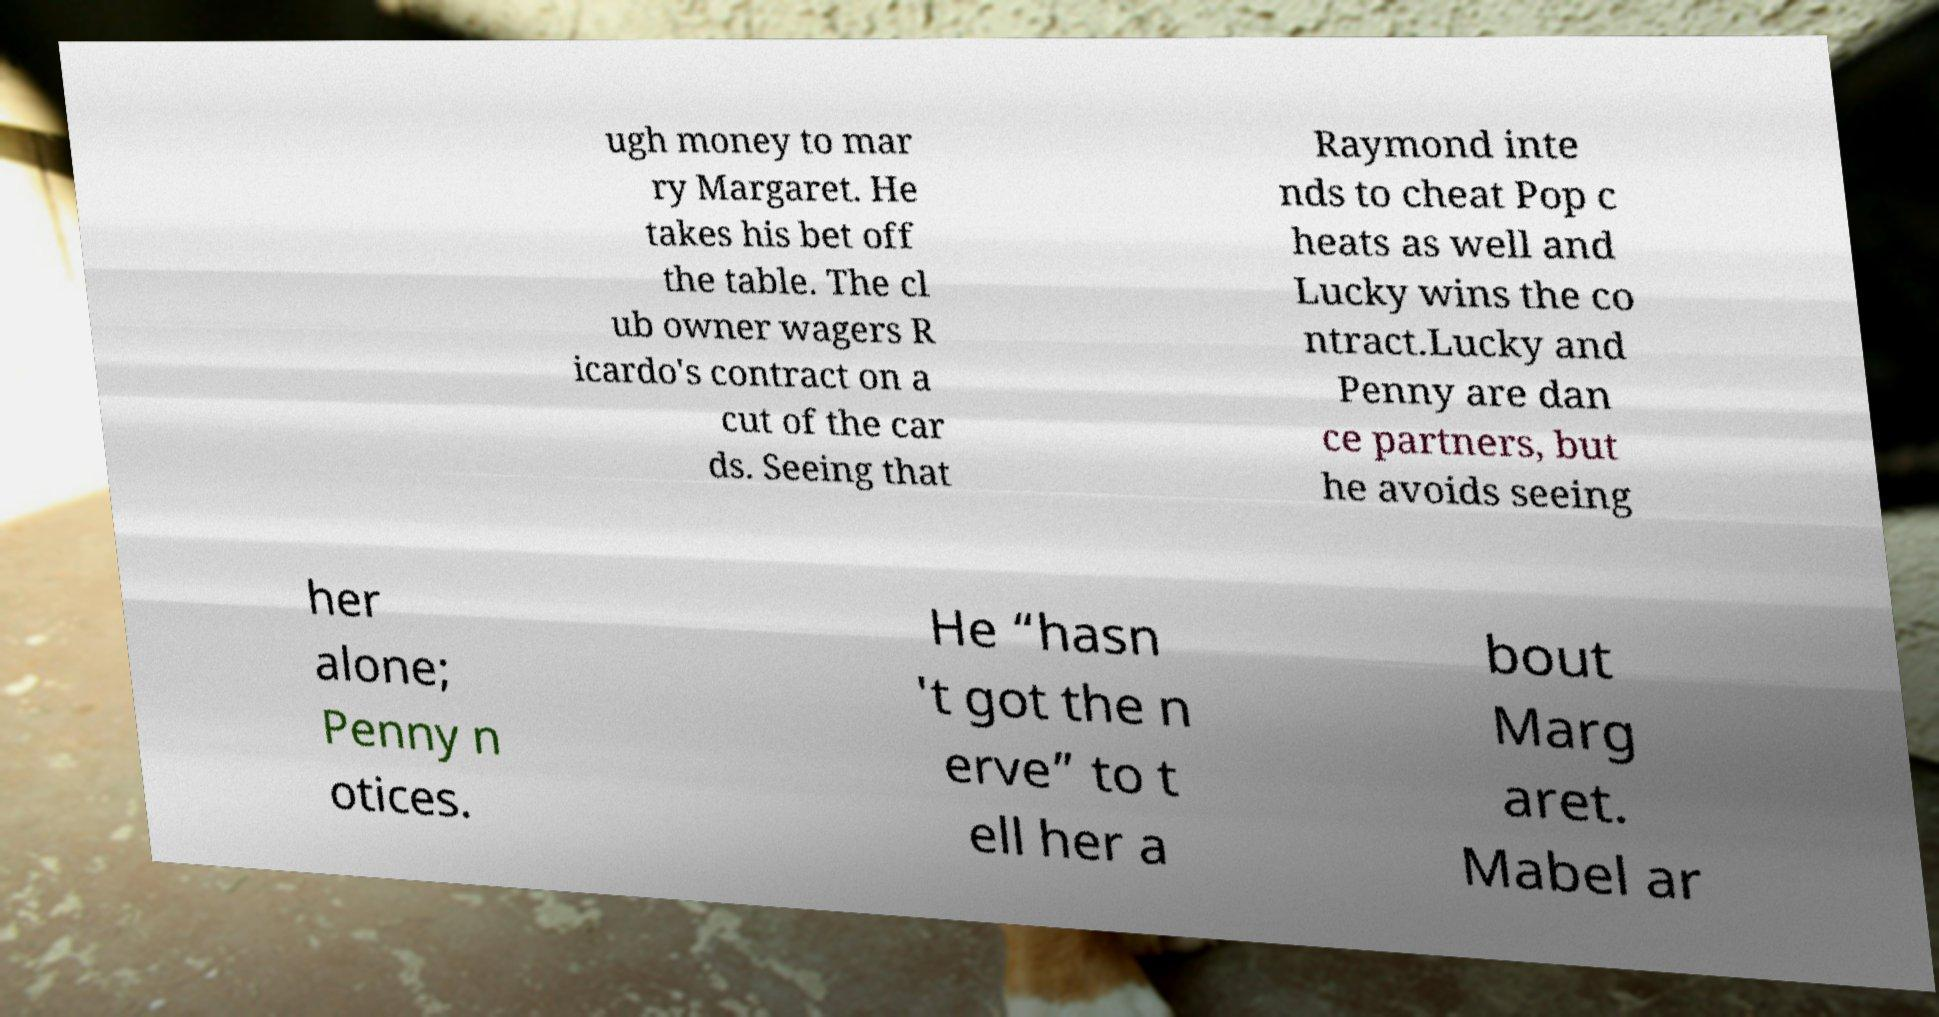I need the written content from this picture converted into text. Can you do that? ugh money to mar ry Margaret. He takes his bet off the table. The cl ub owner wagers R icardo's contract on a cut of the car ds. Seeing that Raymond inte nds to cheat Pop c heats as well and Lucky wins the co ntract.Lucky and Penny are dan ce partners, but he avoids seeing her alone; Penny n otices. He “hasn 't got the n erve” to t ell her a bout Marg aret. Mabel ar 